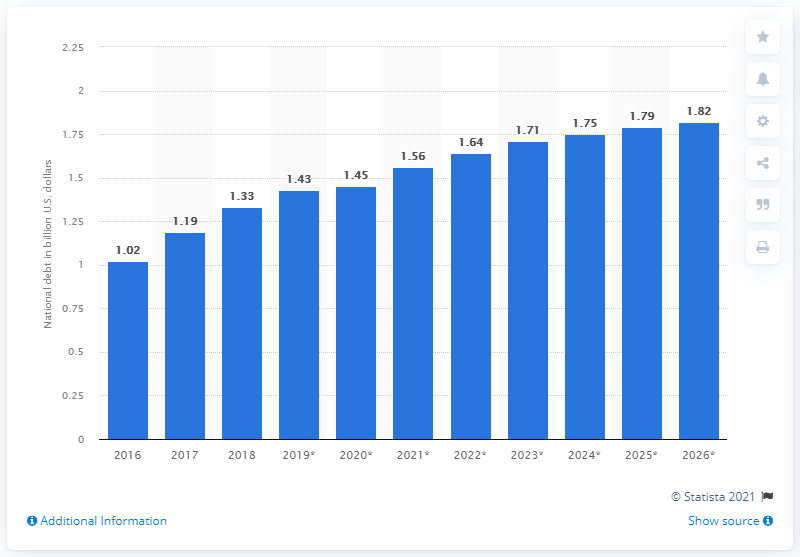Highlight a few significant elements in this photo. The national debt of the Gambia in dollars in 2018 was 1.33. 